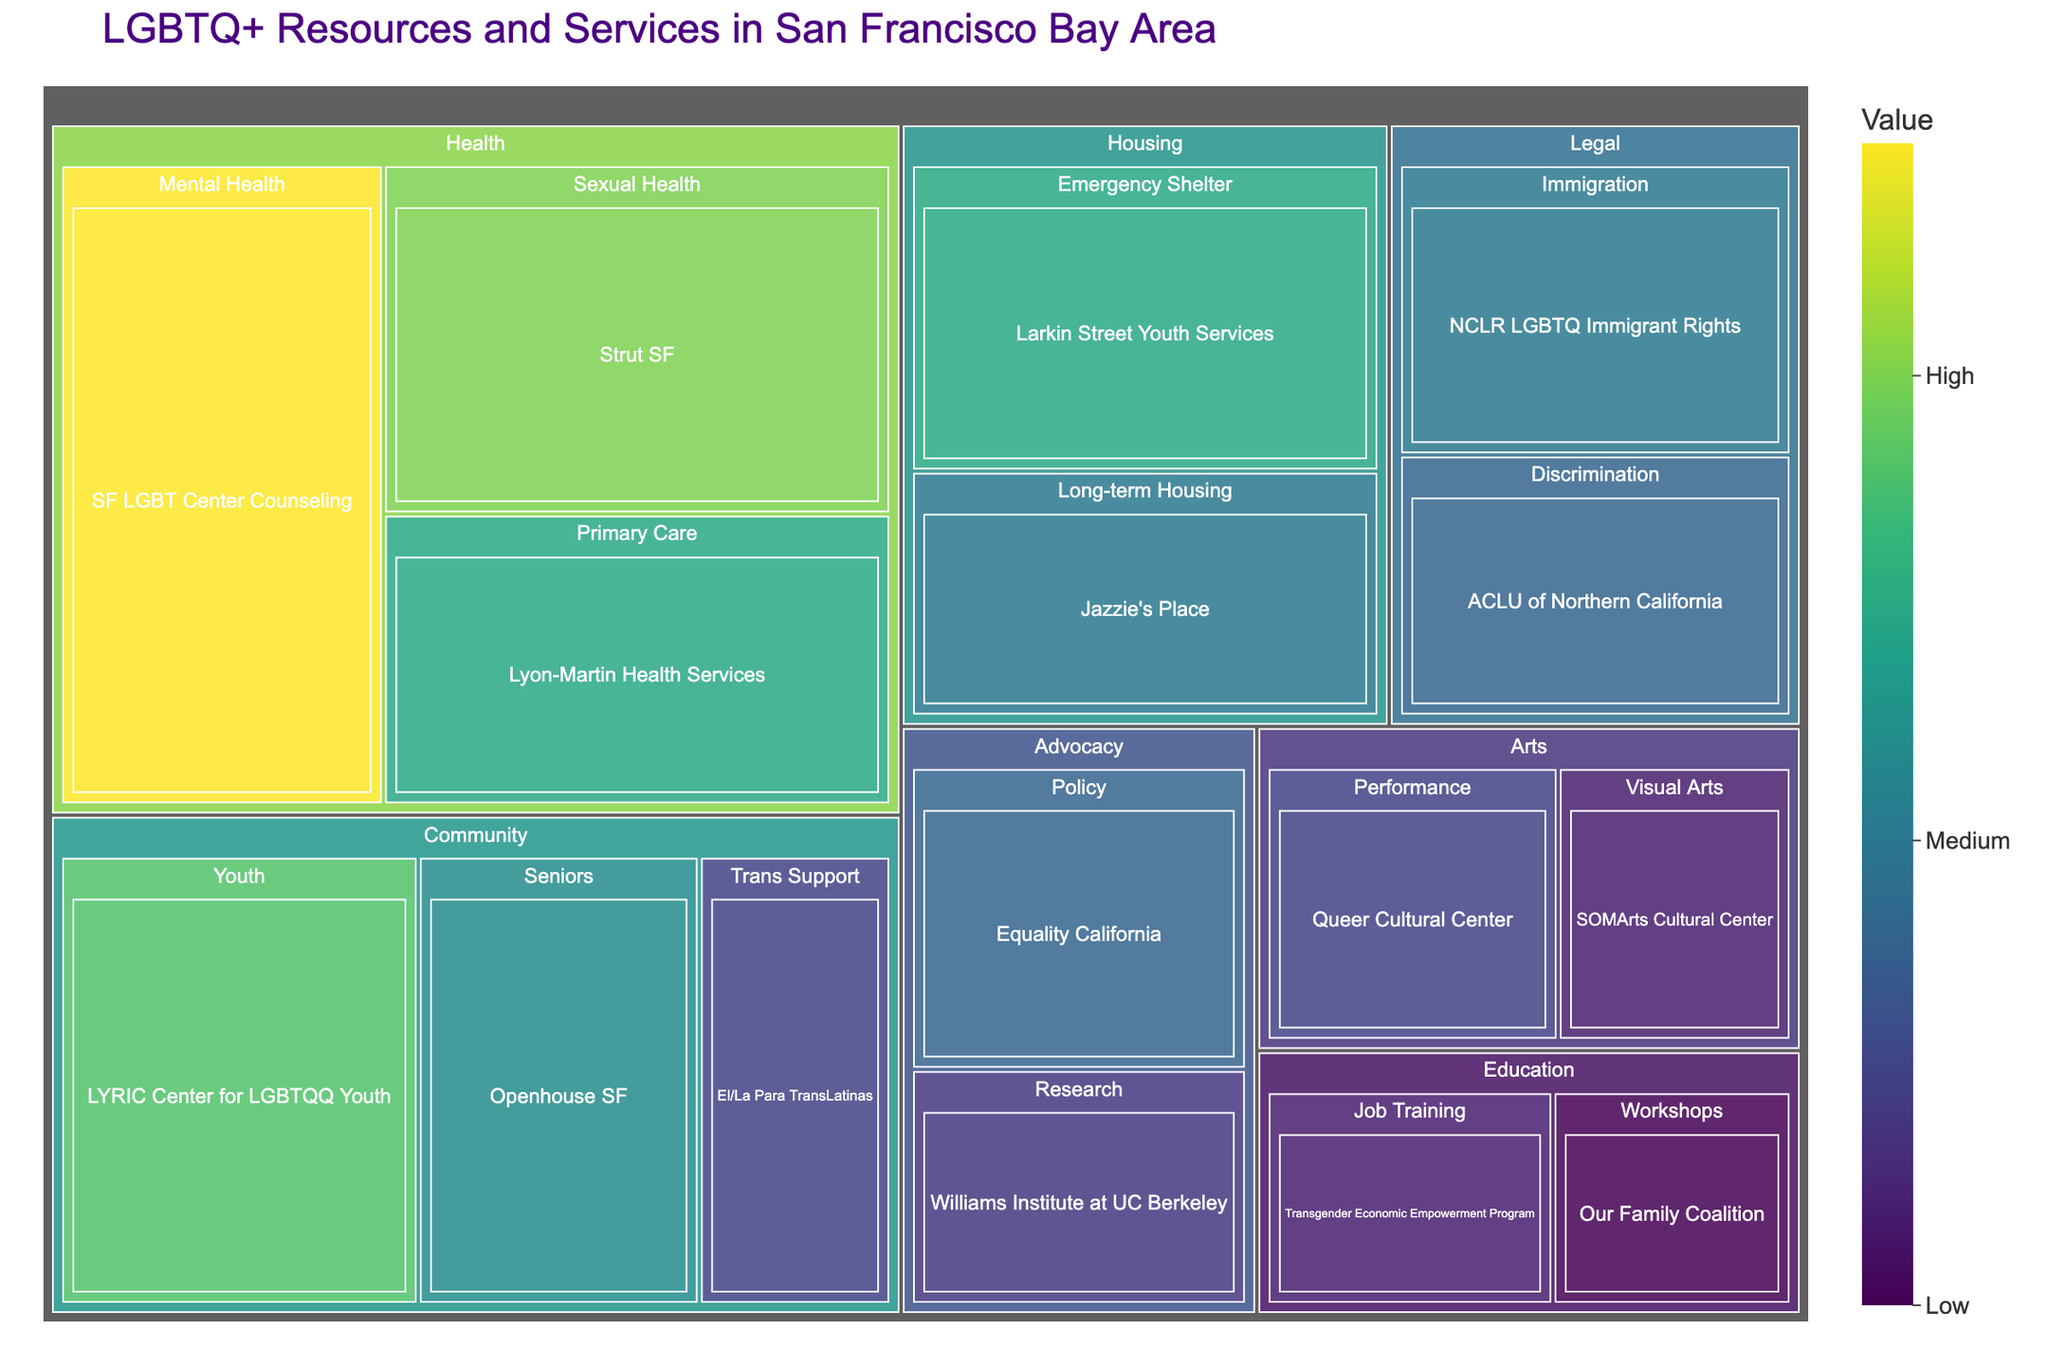What's the title of the treemap? The title of the treemap is displayed at the top of the figure.
Answer: LGBTQ+ Resources and Services in San Francisco Bay Area What category has the highest value service? By looking at the treemap, find the largest block in terms of size and see which category it belongs to.
Answer: Health Which service under 'Community' has the highest value? Locate the 'Community' category in the treemap, observe the subcategories and their corresponding services, and identify the service with the largest block.
Answer: LYRIC Center for LGBTQQ Youth How many services are listed under the 'Health' category? Identify the blocks under the 'Health' category and count each distinct service listed.
Answer: 3 Compare the value of 'Larkin Street Youth Services' and 'Jazzie's Place'. Which one has a higher value? Find both services under the 'Housing' category and compare their values. 'Larkin Street Youth Services' has a value of 25, while 'Jazzie's Place' has a value of 20.
Answer: Larkin Street Youth Services What is the combined value of all the 'Legal' services? Add the values of all services listed under the 'Legal' category: 20 (NCLR LGBTQ Immigrant Rights) + 18 (ACLU of Northern California).
Answer: 38 Which category contains the 'Our Family Coalition' service and what value does it have? Locate the 'Our Family Coalition' service within the treemap and note the corresponding category and value.
Answer: Education; 10 What is the difference in value between 'Williams Institute at UC Berkeley' and 'Equality California'? Find both services under the 'Advocacy' category, note their values, and compute the difference: 18 (Equality California) - 14 (Williams Institute at UC Berkeley).
Answer: 4 Which category has two services with values both equal to or less than 15? Identify categories that have services with values of 15 or less, and ensure there are exactly two such services in that category. 'Arts' has 'Performance' (15) and 'Visual Arts' (12).
Answer: Arts What is the average value of the services under the 'Housing' category? Calculate the average by summing the values of 'Emergency Shelter' and 'Long-term Housing' and dividing by their count: (25 + 20) / 2.
Answer: 22.5 